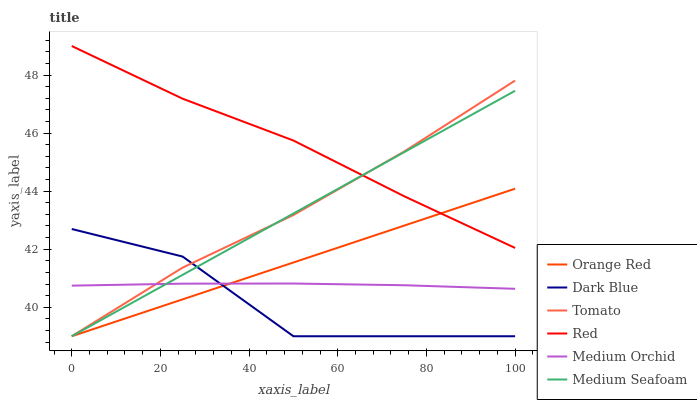Does Dark Blue have the minimum area under the curve?
Answer yes or no. Yes. Does Red have the maximum area under the curve?
Answer yes or no. Yes. Does Medium Orchid have the minimum area under the curve?
Answer yes or no. No. Does Medium Orchid have the maximum area under the curve?
Answer yes or no. No. Is Medium Seafoam the smoothest?
Answer yes or no. Yes. Is Dark Blue the roughest?
Answer yes or no. Yes. Is Medium Orchid the smoothest?
Answer yes or no. No. Is Medium Orchid the roughest?
Answer yes or no. No. Does Medium Orchid have the lowest value?
Answer yes or no. No. Does Red have the highest value?
Answer yes or no. Yes. Does Medium Seafoam have the highest value?
Answer yes or no. No. Is Dark Blue less than Red?
Answer yes or no. Yes. Is Red greater than Medium Orchid?
Answer yes or no. Yes. Does Orange Red intersect Dark Blue?
Answer yes or no. Yes. Is Orange Red less than Dark Blue?
Answer yes or no. No. Is Orange Red greater than Dark Blue?
Answer yes or no. No. Does Dark Blue intersect Red?
Answer yes or no. No. 